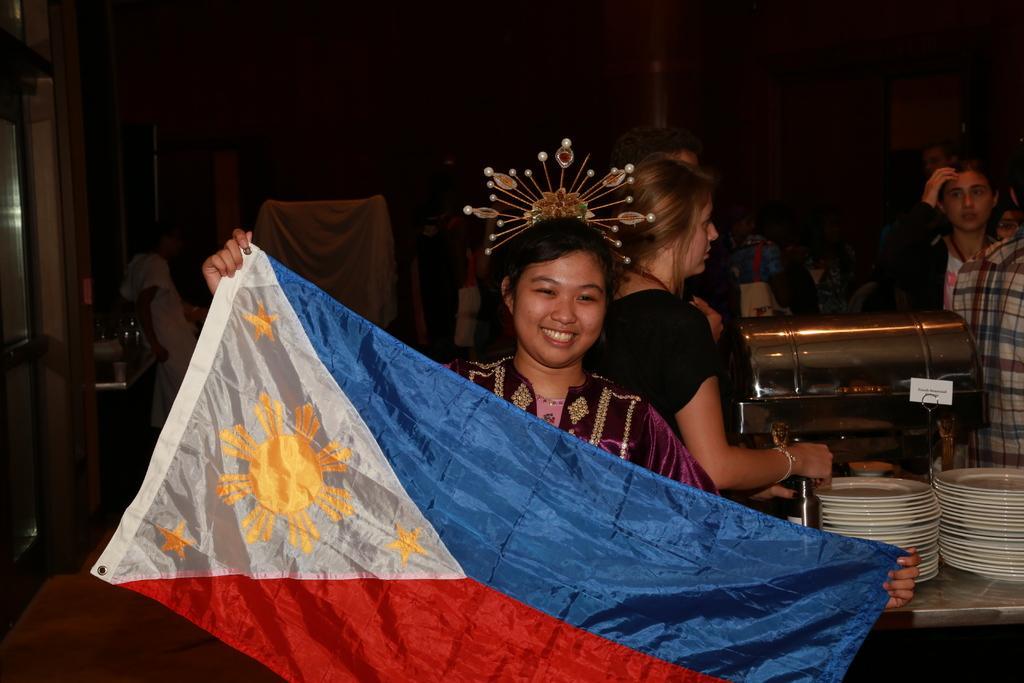In one or two sentences, can you explain what this image depicts? In the picture I can see two women and people are sitting among them the woman in the front is holding a flag in hands. Here I can see white color plates. The background of the image is dark. 